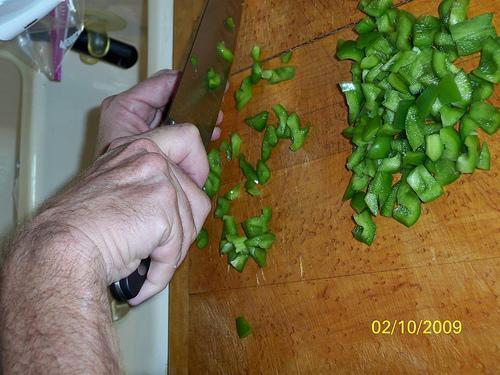How many hands are shown?
Give a very brief answer. 1. 